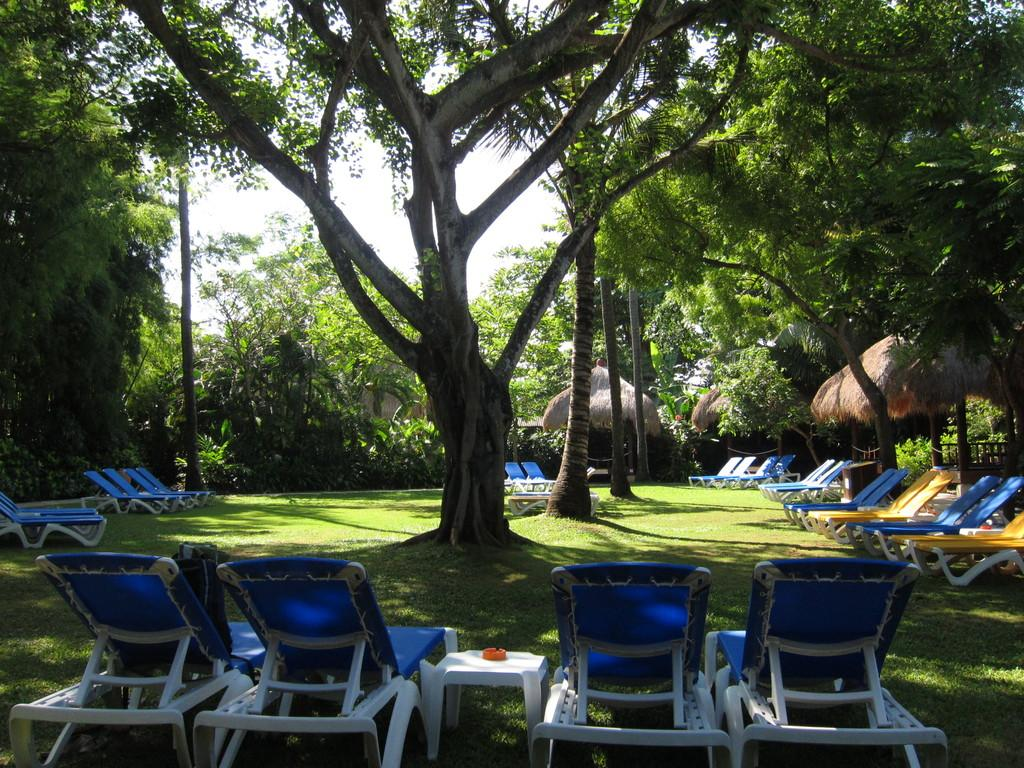What type of seating is visible in the image? There are beach chairs in the image. What type of vegetation is present in the image? There are trees in the image. What is visible at the top of the image? The sky is visible at the top of the image. What type of dirt can be seen on the beach chairs in the image? There is no dirt visible in the image, as it features beach chairs and trees near the sky. In which direction are the beach chairs facing in the image? The direction the beach chairs are facing cannot be determined from the image. 